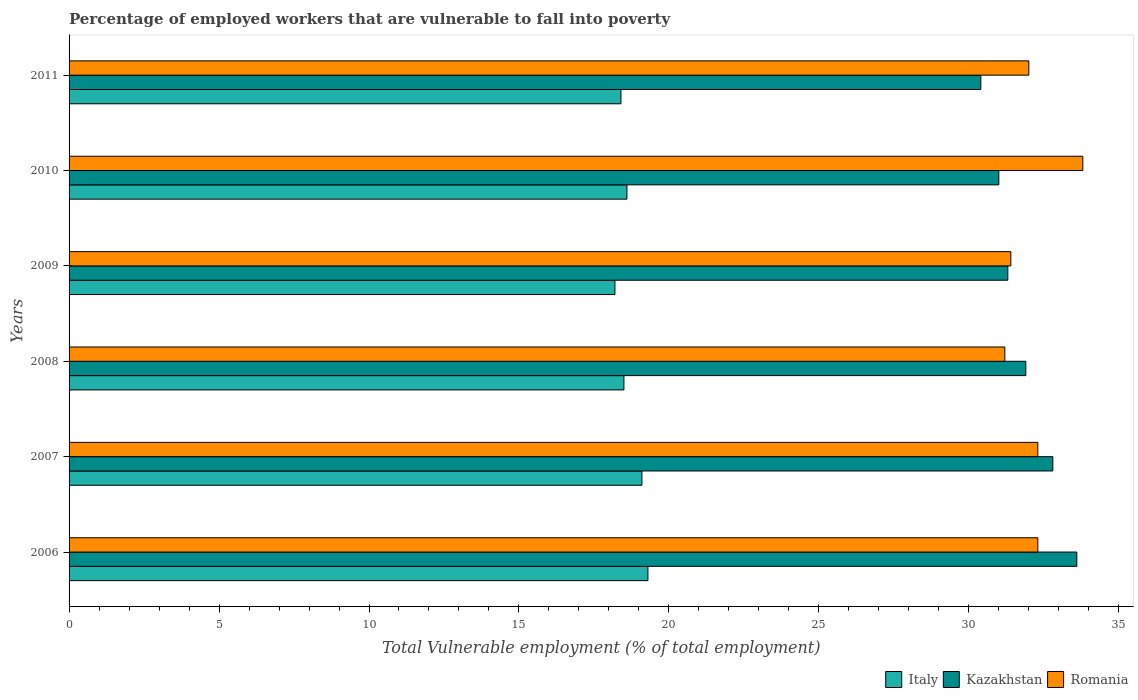How many different coloured bars are there?
Make the answer very short. 3. How many groups of bars are there?
Your answer should be compact. 6. Are the number of bars per tick equal to the number of legend labels?
Your answer should be compact. Yes. How many bars are there on the 6th tick from the top?
Your response must be concise. 3. How many bars are there on the 3rd tick from the bottom?
Your answer should be compact. 3. What is the label of the 6th group of bars from the top?
Your answer should be compact. 2006. What is the percentage of employed workers who are vulnerable to fall into poverty in Italy in 2006?
Offer a terse response. 19.3. Across all years, what is the maximum percentage of employed workers who are vulnerable to fall into poverty in Romania?
Offer a very short reply. 33.8. Across all years, what is the minimum percentage of employed workers who are vulnerable to fall into poverty in Italy?
Your answer should be compact. 18.2. In which year was the percentage of employed workers who are vulnerable to fall into poverty in Romania maximum?
Your answer should be very brief. 2010. In which year was the percentage of employed workers who are vulnerable to fall into poverty in Romania minimum?
Ensure brevity in your answer.  2008. What is the total percentage of employed workers who are vulnerable to fall into poverty in Kazakhstan in the graph?
Give a very brief answer. 191. What is the difference between the percentage of employed workers who are vulnerable to fall into poverty in Kazakhstan in 2007 and that in 2009?
Offer a terse response. 1.5. What is the difference between the percentage of employed workers who are vulnerable to fall into poverty in Italy in 2006 and the percentage of employed workers who are vulnerable to fall into poverty in Romania in 2008?
Provide a succinct answer. -11.9. What is the average percentage of employed workers who are vulnerable to fall into poverty in Romania per year?
Offer a terse response. 32.17. What is the ratio of the percentage of employed workers who are vulnerable to fall into poverty in Romania in 2006 to that in 2008?
Make the answer very short. 1.04. What is the difference between the highest and the second highest percentage of employed workers who are vulnerable to fall into poverty in Kazakhstan?
Ensure brevity in your answer.  0.8. What is the difference between the highest and the lowest percentage of employed workers who are vulnerable to fall into poverty in Romania?
Your response must be concise. 2.6. In how many years, is the percentage of employed workers who are vulnerable to fall into poverty in Romania greater than the average percentage of employed workers who are vulnerable to fall into poverty in Romania taken over all years?
Give a very brief answer. 3. Is the sum of the percentage of employed workers who are vulnerable to fall into poverty in Italy in 2007 and 2010 greater than the maximum percentage of employed workers who are vulnerable to fall into poverty in Kazakhstan across all years?
Provide a short and direct response. Yes. What does the 1st bar from the top in 2009 represents?
Give a very brief answer. Romania. What does the 1st bar from the bottom in 2006 represents?
Make the answer very short. Italy. Is it the case that in every year, the sum of the percentage of employed workers who are vulnerable to fall into poverty in Italy and percentage of employed workers who are vulnerable to fall into poverty in Kazakhstan is greater than the percentage of employed workers who are vulnerable to fall into poverty in Romania?
Give a very brief answer. Yes. Are all the bars in the graph horizontal?
Provide a short and direct response. Yes. How many years are there in the graph?
Your response must be concise. 6. Does the graph contain any zero values?
Your response must be concise. No. How many legend labels are there?
Your response must be concise. 3. How are the legend labels stacked?
Offer a terse response. Horizontal. What is the title of the graph?
Your answer should be compact. Percentage of employed workers that are vulnerable to fall into poverty. What is the label or title of the X-axis?
Offer a very short reply. Total Vulnerable employment (% of total employment). What is the Total Vulnerable employment (% of total employment) of Italy in 2006?
Keep it short and to the point. 19.3. What is the Total Vulnerable employment (% of total employment) in Kazakhstan in 2006?
Offer a terse response. 33.6. What is the Total Vulnerable employment (% of total employment) in Romania in 2006?
Your response must be concise. 32.3. What is the Total Vulnerable employment (% of total employment) in Italy in 2007?
Your answer should be very brief. 19.1. What is the Total Vulnerable employment (% of total employment) in Kazakhstan in 2007?
Your response must be concise. 32.8. What is the Total Vulnerable employment (% of total employment) of Romania in 2007?
Ensure brevity in your answer.  32.3. What is the Total Vulnerable employment (% of total employment) in Kazakhstan in 2008?
Offer a terse response. 31.9. What is the Total Vulnerable employment (% of total employment) of Romania in 2008?
Make the answer very short. 31.2. What is the Total Vulnerable employment (% of total employment) of Italy in 2009?
Keep it short and to the point. 18.2. What is the Total Vulnerable employment (% of total employment) of Kazakhstan in 2009?
Provide a succinct answer. 31.3. What is the Total Vulnerable employment (% of total employment) in Romania in 2009?
Give a very brief answer. 31.4. What is the Total Vulnerable employment (% of total employment) of Italy in 2010?
Provide a succinct answer. 18.6. What is the Total Vulnerable employment (% of total employment) of Romania in 2010?
Give a very brief answer. 33.8. What is the Total Vulnerable employment (% of total employment) in Italy in 2011?
Give a very brief answer. 18.4. What is the Total Vulnerable employment (% of total employment) in Kazakhstan in 2011?
Offer a terse response. 30.4. Across all years, what is the maximum Total Vulnerable employment (% of total employment) in Italy?
Provide a succinct answer. 19.3. Across all years, what is the maximum Total Vulnerable employment (% of total employment) in Kazakhstan?
Your answer should be very brief. 33.6. Across all years, what is the maximum Total Vulnerable employment (% of total employment) in Romania?
Offer a terse response. 33.8. Across all years, what is the minimum Total Vulnerable employment (% of total employment) in Italy?
Keep it short and to the point. 18.2. Across all years, what is the minimum Total Vulnerable employment (% of total employment) of Kazakhstan?
Make the answer very short. 30.4. Across all years, what is the minimum Total Vulnerable employment (% of total employment) in Romania?
Your answer should be compact. 31.2. What is the total Total Vulnerable employment (% of total employment) in Italy in the graph?
Keep it short and to the point. 112.1. What is the total Total Vulnerable employment (% of total employment) in Kazakhstan in the graph?
Provide a short and direct response. 191. What is the total Total Vulnerable employment (% of total employment) in Romania in the graph?
Offer a terse response. 193. What is the difference between the Total Vulnerable employment (% of total employment) of Italy in 2006 and that in 2007?
Your answer should be compact. 0.2. What is the difference between the Total Vulnerable employment (% of total employment) of Kazakhstan in 2006 and that in 2008?
Keep it short and to the point. 1.7. What is the difference between the Total Vulnerable employment (% of total employment) of Italy in 2006 and that in 2009?
Give a very brief answer. 1.1. What is the difference between the Total Vulnerable employment (% of total employment) in Italy in 2006 and that in 2010?
Ensure brevity in your answer.  0.7. What is the difference between the Total Vulnerable employment (% of total employment) in Kazakhstan in 2006 and that in 2010?
Make the answer very short. 2.6. What is the difference between the Total Vulnerable employment (% of total employment) in Kazakhstan in 2007 and that in 2008?
Provide a short and direct response. 0.9. What is the difference between the Total Vulnerable employment (% of total employment) of Romania in 2007 and that in 2008?
Ensure brevity in your answer.  1.1. What is the difference between the Total Vulnerable employment (% of total employment) of Kazakhstan in 2007 and that in 2009?
Keep it short and to the point. 1.5. What is the difference between the Total Vulnerable employment (% of total employment) of Romania in 2007 and that in 2009?
Offer a terse response. 0.9. What is the difference between the Total Vulnerable employment (% of total employment) of Italy in 2007 and that in 2010?
Your answer should be very brief. 0.5. What is the difference between the Total Vulnerable employment (% of total employment) of Romania in 2007 and that in 2010?
Make the answer very short. -1.5. What is the difference between the Total Vulnerable employment (% of total employment) in Kazakhstan in 2007 and that in 2011?
Ensure brevity in your answer.  2.4. What is the difference between the Total Vulnerable employment (% of total employment) of Romania in 2007 and that in 2011?
Offer a terse response. 0.3. What is the difference between the Total Vulnerable employment (% of total employment) in Italy in 2008 and that in 2009?
Keep it short and to the point. 0.3. What is the difference between the Total Vulnerable employment (% of total employment) in Kazakhstan in 2008 and that in 2010?
Provide a succinct answer. 0.9. What is the difference between the Total Vulnerable employment (% of total employment) of Romania in 2008 and that in 2010?
Your answer should be very brief. -2.6. What is the difference between the Total Vulnerable employment (% of total employment) of Italy in 2009 and that in 2010?
Keep it short and to the point. -0.4. What is the difference between the Total Vulnerable employment (% of total employment) in Kazakhstan in 2009 and that in 2010?
Offer a terse response. 0.3. What is the difference between the Total Vulnerable employment (% of total employment) in Romania in 2009 and that in 2010?
Your response must be concise. -2.4. What is the difference between the Total Vulnerable employment (% of total employment) in Italy in 2009 and that in 2011?
Offer a terse response. -0.2. What is the difference between the Total Vulnerable employment (% of total employment) of Kazakhstan in 2009 and that in 2011?
Offer a very short reply. 0.9. What is the difference between the Total Vulnerable employment (% of total employment) of Romania in 2009 and that in 2011?
Provide a succinct answer. -0.6. What is the difference between the Total Vulnerable employment (% of total employment) in Italy in 2010 and that in 2011?
Make the answer very short. 0.2. What is the difference between the Total Vulnerable employment (% of total employment) of Romania in 2010 and that in 2011?
Your answer should be very brief. 1.8. What is the difference between the Total Vulnerable employment (% of total employment) in Italy in 2006 and the Total Vulnerable employment (% of total employment) in Kazakhstan in 2007?
Give a very brief answer. -13.5. What is the difference between the Total Vulnerable employment (% of total employment) in Italy in 2006 and the Total Vulnerable employment (% of total employment) in Romania in 2007?
Provide a short and direct response. -13. What is the difference between the Total Vulnerable employment (% of total employment) in Kazakhstan in 2006 and the Total Vulnerable employment (% of total employment) in Romania in 2007?
Give a very brief answer. 1.3. What is the difference between the Total Vulnerable employment (% of total employment) of Italy in 2006 and the Total Vulnerable employment (% of total employment) of Kazakhstan in 2008?
Provide a succinct answer. -12.6. What is the difference between the Total Vulnerable employment (% of total employment) of Italy in 2006 and the Total Vulnerable employment (% of total employment) of Romania in 2009?
Offer a terse response. -12.1. What is the difference between the Total Vulnerable employment (% of total employment) of Kazakhstan in 2006 and the Total Vulnerable employment (% of total employment) of Romania in 2009?
Offer a terse response. 2.2. What is the difference between the Total Vulnerable employment (% of total employment) of Italy in 2006 and the Total Vulnerable employment (% of total employment) of Kazakhstan in 2010?
Provide a short and direct response. -11.7. What is the difference between the Total Vulnerable employment (% of total employment) in Kazakhstan in 2007 and the Total Vulnerable employment (% of total employment) in Romania in 2008?
Offer a very short reply. 1.6. What is the difference between the Total Vulnerable employment (% of total employment) of Italy in 2007 and the Total Vulnerable employment (% of total employment) of Kazakhstan in 2009?
Give a very brief answer. -12.2. What is the difference between the Total Vulnerable employment (% of total employment) of Italy in 2007 and the Total Vulnerable employment (% of total employment) of Romania in 2010?
Your answer should be very brief. -14.7. What is the difference between the Total Vulnerable employment (% of total employment) in Italy in 2007 and the Total Vulnerable employment (% of total employment) in Kazakhstan in 2011?
Provide a succinct answer. -11.3. What is the difference between the Total Vulnerable employment (% of total employment) in Italy in 2007 and the Total Vulnerable employment (% of total employment) in Romania in 2011?
Ensure brevity in your answer.  -12.9. What is the difference between the Total Vulnerable employment (% of total employment) of Kazakhstan in 2007 and the Total Vulnerable employment (% of total employment) of Romania in 2011?
Offer a very short reply. 0.8. What is the difference between the Total Vulnerable employment (% of total employment) of Italy in 2008 and the Total Vulnerable employment (% of total employment) of Romania in 2009?
Provide a short and direct response. -12.9. What is the difference between the Total Vulnerable employment (% of total employment) of Kazakhstan in 2008 and the Total Vulnerable employment (% of total employment) of Romania in 2009?
Your response must be concise. 0.5. What is the difference between the Total Vulnerable employment (% of total employment) of Italy in 2008 and the Total Vulnerable employment (% of total employment) of Kazakhstan in 2010?
Your answer should be very brief. -12.5. What is the difference between the Total Vulnerable employment (% of total employment) in Italy in 2008 and the Total Vulnerable employment (% of total employment) in Romania in 2010?
Your response must be concise. -15.3. What is the difference between the Total Vulnerable employment (% of total employment) in Kazakhstan in 2008 and the Total Vulnerable employment (% of total employment) in Romania in 2011?
Ensure brevity in your answer.  -0.1. What is the difference between the Total Vulnerable employment (% of total employment) of Italy in 2009 and the Total Vulnerable employment (% of total employment) of Romania in 2010?
Your response must be concise. -15.6. What is the difference between the Total Vulnerable employment (% of total employment) in Kazakhstan in 2009 and the Total Vulnerable employment (% of total employment) in Romania in 2010?
Give a very brief answer. -2.5. What is the difference between the Total Vulnerable employment (% of total employment) of Italy in 2009 and the Total Vulnerable employment (% of total employment) of Kazakhstan in 2011?
Give a very brief answer. -12.2. What is the difference between the Total Vulnerable employment (% of total employment) in Kazakhstan in 2009 and the Total Vulnerable employment (% of total employment) in Romania in 2011?
Give a very brief answer. -0.7. What is the difference between the Total Vulnerable employment (% of total employment) of Italy in 2010 and the Total Vulnerable employment (% of total employment) of Kazakhstan in 2011?
Your response must be concise. -11.8. What is the difference between the Total Vulnerable employment (% of total employment) of Italy in 2010 and the Total Vulnerable employment (% of total employment) of Romania in 2011?
Give a very brief answer. -13.4. What is the average Total Vulnerable employment (% of total employment) of Italy per year?
Keep it short and to the point. 18.68. What is the average Total Vulnerable employment (% of total employment) in Kazakhstan per year?
Keep it short and to the point. 31.83. What is the average Total Vulnerable employment (% of total employment) in Romania per year?
Keep it short and to the point. 32.17. In the year 2006, what is the difference between the Total Vulnerable employment (% of total employment) of Italy and Total Vulnerable employment (% of total employment) of Kazakhstan?
Your answer should be compact. -14.3. In the year 2006, what is the difference between the Total Vulnerable employment (% of total employment) in Italy and Total Vulnerable employment (% of total employment) in Romania?
Your answer should be compact. -13. In the year 2007, what is the difference between the Total Vulnerable employment (% of total employment) of Italy and Total Vulnerable employment (% of total employment) of Kazakhstan?
Offer a terse response. -13.7. In the year 2007, what is the difference between the Total Vulnerable employment (% of total employment) of Italy and Total Vulnerable employment (% of total employment) of Romania?
Your response must be concise. -13.2. In the year 2008, what is the difference between the Total Vulnerable employment (% of total employment) of Italy and Total Vulnerable employment (% of total employment) of Kazakhstan?
Your response must be concise. -13.4. In the year 2009, what is the difference between the Total Vulnerable employment (% of total employment) of Italy and Total Vulnerable employment (% of total employment) of Kazakhstan?
Give a very brief answer. -13.1. In the year 2009, what is the difference between the Total Vulnerable employment (% of total employment) in Italy and Total Vulnerable employment (% of total employment) in Romania?
Make the answer very short. -13.2. In the year 2009, what is the difference between the Total Vulnerable employment (% of total employment) in Kazakhstan and Total Vulnerable employment (% of total employment) in Romania?
Offer a very short reply. -0.1. In the year 2010, what is the difference between the Total Vulnerable employment (% of total employment) in Italy and Total Vulnerable employment (% of total employment) in Kazakhstan?
Ensure brevity in your answer.  -12.4. In the year 2010, what is the difference between the Total Vulnerable employment (% of total employment) of Italy and Total Vulnerable employment (% of total employment) of Romania?
Ensure brevity in your answer.  -15.2. In the year 2011, what is the difference between the Total Vulnerable employment (% of total employment) of Italy and Total Vulnerable employment (% of total employment) of Kazakhstan?
Offer a terse response. -12. In the year 2011, what is the difference between the Total Vulnerable employment (% of total employment) in Kazakhstan and Total Vulnerable employment (% of total employment) in Romania?
Keep it short and to the point. -1.6. What is the ratio of the Total Vulnerable employment (% of total employment) of Italy in 2006 to that in 2007?
Make the answer very short. 1.01. What is the ratio of the Total Vulnerable employment (% of total employment) in Kazakhstan in 2006 to that in 2007?
Make the answer very short. 1.02. What is the ratio of the Total Vulnerable employment (% of total employment) of Romania in 2006 to that in 2007?
Keep it short and to the point. 1. What is the ratio of the Total Vulnerable employment (% of total employment) of Italy in 2006 to that in 2008?
Ensure brevity in your answer.  1.04. What is the ratio of the Total Vulnerable employment (% of total employment) in Kazakhstan in 2006 to that in 2008?
Keep it short and to the point. 1.05. What is the ratio of the Total Vulnerable employment (% of total employment) in Romania in 2006 to that in 2008?
Ensure brevity in your answer.  1.04. What is the ratio of the Total Vulnerable employment (% of total employment) of Italy in 2006 to that in 2009?
Provide a short and direct response. 1.06. What is the ratio of the Total Vulnerable employment (% of total employment) in Kazakhstan in 2006 to that in 2009?
Make the answer very short. 1.07. What is the ratio of the Total Vulnerable employment (% of total employment) of Romania in 2006 to that in 2009?
Make the answer very short. 1.03. What is the ratio of the Total Vulnerable employment (% of total employment) of Italy in 2006 to that in 2010?
Provide a succinct answer. 1.04. What is the ratio of the Total Vulnerable employment (% of total employment) in Kazakhstan in 2006 to that in 2010?
Keep it short and to the point. 1.08. What is the ratio of the Total Vulnerable employment (% of total employment) of Romania in 2006 to that in 2010?
Give a very brief answer. 0.96. What is the ratio of the Total Vulnerable employment (% of total employment) of Italy in 2006 to that in 2011?
Offer a terse response. 1.05. What is the ratio of the Total Vulnerable employment (% of total employment) of Kazakhstan in 2006 to that in 2011?
Your response must be concise. 1.11. What is the ratio of the Total Vulnerable employment (% of total employment) of Romania in 2006 to that in 2011?
Your answer should be compact. 1.01. What is the ratio of the Total Vulnerable employment (% of total employment) in Italy in 2007 to that in 2008?
Ensure brevity in your answer.  1.03. What is the ratio of the Total Vulnerable employment (% of total employment) in Kazakhstan in 2007 to that in 2008?
Offer a very short reply. 1.03. What is the ratio of the Total Vulnerable employment (% of total employment) of Romania in 2007 to that in 2008?
Provide a short and direct response. 1.04. What is the ratio of the Total Vulnerable employment (% of total employment) of Italy in 2007 to that in 2009?
Ensure brevity in your answer.  1.05. What is the ratio of the Total Vulnerable employment (% of total employment) of Kazakhstan in 2007 to that in 2009?
Your response must be concise. 1.05. What is the ratio of the Total Vulnerable employment (% of total employment) in Romania in 2007 to that in 2009?
Offer a terse response. 1.03. What is the ratio of the Total Vulnerable employment (% of total employment) in Italy in 2007 to that in 2010?
Your answer should be very brief. 1.03. What is the ratio of the Total Vulnerable employment (% of total employment) of Kazakhstan in 2007 to that in 2010?
Your response must be concise. 1.06. What is the ratio of the Total Vulnerable employment (% of total employment) in Romania in 2007 to that in 2010?
Ensure brevity in your answer.  0.96. What is the ratio of the Total Vulnerable employment (% of total employment) in Italy in 2007 to that in 2011?
Your response must be concise. 1.04. What is the ratio of the Total Vulnerable employment (% of total employment) of Kazakhstan in 2007 to that in 2011?
Provide a short and direct response. 1.08. What is the ratio of the Total Vulnerable employment (% of total employment) in Romania in 2007 to that in 2011?
Your response must be concise. 1.01. What is the ratio of the Total Vulnerable employment (% of total employment) of Italy in 2008 to that in 2009?
Offer a terse response. 1.02. What is the ratio of the Total Vulnerable employment (% of total employment) of Kazakhstan in 2008 to that in 2009?
Keep it short and to the point. 1.02. What is the ratio of the Total Vulnerable employment (% of total employment) in Romania in 2008 to that in 2009?
Keep it short and to the point. 0.99. What is the ratio of the Total Vulnerable employment (% of total employment) in Italy in 2008 to that in 2010?
Provide a succinct answer. 0.99. What is the ratio of the Total Vulnerable employment (% of total employment) in Kazakhstan in 2008 to that in 2010?
Ensure brevity in your answer.  1.03. What is the ratio of the Total Vulnerable employment (% of total employment) in Romania in 2008 to that in 2010?
Offer a terse response. 0.92. What is the ratio of the Total Vulnerable employment (% of total employment) in Italy in 2008 to that in 2011?
Keep it short and to the point. 1.01. What is the ratio of the Total Vulnerable employment (% of total employment) of Kazakhstan in 2008 to that in 2011?
Provide a succinct answer. 1.05. What is the ratio of the Total Vulnerable employment (% of total employment) in Italy in 2009 to that in 2010?
Ensure brevity in your answer.  0.98. What is the ratio of the Total Vulnerable employment (% of total employment) in Kazakhstan in 2009 to that in 2010?
Give a very brief answer. 1.01. What is the ratio of the Total Vulnerable employment (% of total employment) in Romania in 2009 to that in 2010?
Your answer should be compact. 0.93. What is the ratio of the Total Vulnerable employment (% of total employment) in Italy in 2009 to that in 2011?
Provide a short and direct response. 0.99. What is the ratio of the Total Vulnerable employment (% of total employment) of Kazakhstan in 2009 to that in 2011?
Your answer should be compact. 1.03. What is the ratio of the Total Vulnerable employment (% of total employment) of Romania in 2009 to that in 2011?
Offer a very short reply. 0.98. What is the ratio of the Total Vulnerable employment (% of total employment) of Italy in 2010 to that in 2011?
Make the answer very short. 1.01. What is the ratio of the Total Vulnerable employment (% of total employment) of Kazakhstan in 2010 to that in 2011?
Ensure brevity in your answer.  1.02. What is the ratio of the Total Vulnerable employment (% of total employment) in Romania in 2010 to that in 2011?
Your answer should be very brief. 1.06. What is the difference between the highest and the second highest Total Vulnerable employment (% of total employment) of Italy?
Your response must be concise. 0.2. What is the difference between the highest and the second highest Total Vulnerable employment (% of total employment) of Romania?
Your answer should be very brief. 1.5. What is the difference between the highest and the lowest Total Vulnerable employment (% of total employment) of Romania?
Your answer should be very brief. 2.6. 